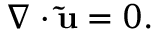Convert formula to latex. <formula><loc_0><loc_0><loc_500><loc_500>\boldsymbol \nabla \cdot \tilde { u } = 0 .</formula> 